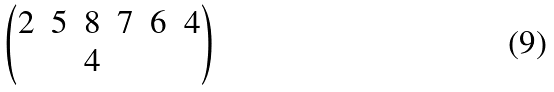<formula> <loc_0><loc_0><loc_500><loc_500>\begin{pmatrix} 2 & 5 & 8 & 7 & 6 & 4 \\ & & 4 & & & \end{pmatrix}</formula> 